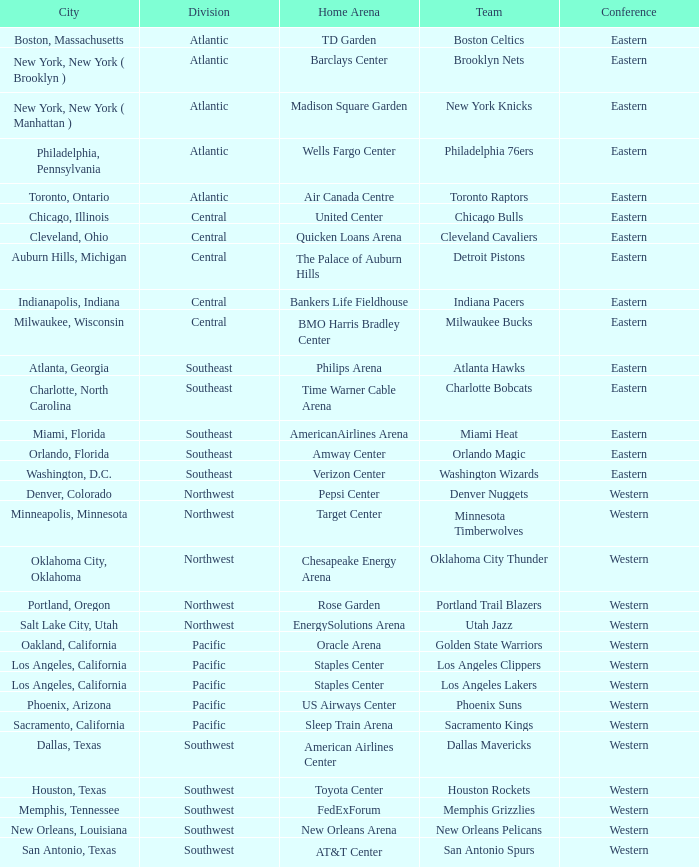Which city includes Barclays Center? New York, New York ( Brooklyn ). I'm looking to parse the entire table for insights. Could you assist me with that? {'header': ['City', 'Division', 'Home Arena', 'Team', 'Conference'], 'rows': [['Boston, Massachusetts', 'Atlantic', 'TD Garden', 'Boston Celtics', 'Eastern'], ['New York, New York ( Brooklyn )', 'Atlantic', 'Barclays Center', 'Brooklyn Nets', 'Eastern'], ['New York, New York ( Manhattan )', 'Atlantic', 'Madison Square Garden', 'New York Knicks', 'Eastern'], ['Philadelphia, Pennsylvania', 'Atlantic', 'Wells Fargo Center', 'Philadelphia 76ers', 'Eastern'], ['Toronto, Ontario', 'Atlantic', 'Air Canada Centre', 'Toronto Raptors', 'Eastern'], ['Chicago, Illinois', 'Central', 'United Center', 'Chicago Bulls', 'Eastern'], ['Cleveland, Ohio', 'Central', 'Quicken Loans Arena', 'Cleveland Cavaliers', 'Eastern'], ['Auburn Hills, Michigan', 'Central', 'The Palace of Auburn Hills', 'Detroit Pistons', 'Eastern'], ['Indianapolis, Indiana', 'Central', 'Bankers Life Fieldhouse', 'Indiana Pacers', 'Eastern'], ['Milwaukee, Wisconsin', 'Central', 'BMO Harris Bradley Center', 'Milwaukee Bucks', 'Eastern'], ['Atlanta, Georgia', 'Southeast', 'Philips Arena', 'Atlanta Hawks', 'Eastern'], ['Charlotte, North Carolina', 'Southeast', 'Time Warner Cable Arena', 'Charlotte Bobcats', 'Eastern'], ['Miami, Florida', 'Southeast', 'AmericanAirlines Arena', 'Miami Heat', 'Eastern'], ['Orlando, Florida', 'Southeast', 'Amway Center', 'Orlando Magic', 'Eastern'], ['Washington, D.C.', 'Southeast', 'Verizon Center', 'Washington Wizards', 'Eastern'], ['Denver, Colorado', 'Northwest', 'Pepsi Center', 'Denver Nuggets', 'Western'], ['Minneapolis, Minnesota', 'Northwest', 'Target Center', 'Minnesota Timberwolves', 'Western'], ['Oklahoma City, Oklahoma', 'Northwest', 'Chesapeake Energy Arena', 'Oklahoma City Thunder', 'Western'], ['Portland, Oregon', 'Northwest', 'Rose Garden', 'Portland Trail Blazers', 'Western'], ['Salt Lake City, Utah', 'Northwest', 'EnergySolutions Arena', 'Utah Jazz', 'Western'], ['Oakland, California', 'Pacific', 'Oracle Arena', 'Golden State Warriors', 'Western'], ['Los Angeles, California', 'Pacific', 'Staples Center', 'Los Angeles Clippers', 'Western'], ['Los Angeles, California', 'Pacific', 'Staples Center', 'Los Angeles Lakers', 'Western'], ['Phoenix, Arizona', 'Pacific', 'US Airways Center', 'Phoenix Suns', 'Western'], ['Sacramento, California', 'Pacific', 'Sleep Train Arena', 'Sacramento Kings', 'Western'], ['Dallas, Texas', 'Southwest', 'American Airlines Center', 'Dallas Mavericks', 'Western'], ['Houston, Texas', 'Southwest', 'Toyota Center', 'Houston Rockets', 'Western'], ['Memphis, Tennessee', 'Southwest', 'FedExForum', 'Memphis Grizzlies', 'Western'], ['New Orleans, Louisiana', 'Southwest', 'New Orleans Arena', 'New Orleans Pelicans', 'Western'], ['San Antonio, Texas', 'Southwest', 'AT&T Center', 'San Antonio Spurs', 'Western']]} 